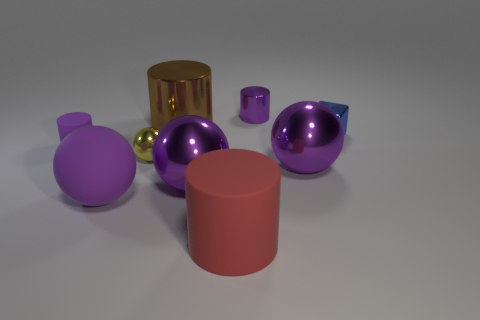Subtract all purple balls. How many were subtracted if there are1purple balls left? 2 Subtract all red blocks. How many purple spheres are left? 3 Subtract 1 spheres. How many spheres are left? 3 Subtract all cylinders. How many objects are left? 5 Subtract 0 gray cylinders. How many objects are left? 9 Subtract all small purple metallic spheres. Subtract all big shiny spheres. How many objects are left? 7 Add 7 small yellow metal balls. How many small yellow metal balls are left? 8 Add 8 large green rubber blocks. How many large green rubber blocks exist? 8 